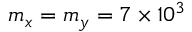<formula> <loc_0><loc_0><loc_500><loc_500>m _ { x } = m _ { y } = 7 \times 1 0 ^ { 3 }</formula> 